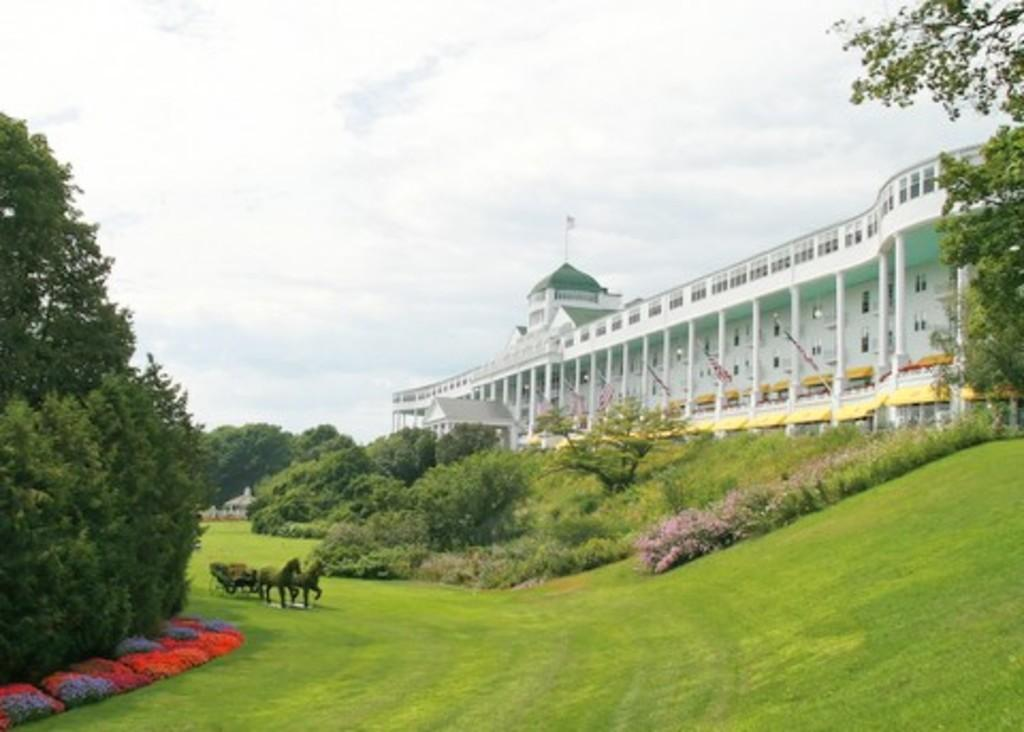What animals can be seen in the image? There are horses in the image. What is being pulled by the horses? There is a cart in the image. What type of vegetation is present in the image? There are plants, grass, flowers, and trees in the image. What type of structure can be seen in the image? There is a building in the image. What decorative elements are present in the image? There are flags in the image. What additional structure can be seen in the image? There is a shed in the image. What can be seen in the background of the image? The sky is visible in the background of the image, with clouds present. What type of silk material is draped over the horses in the image? There is no silk material present in the image; the horses are not draped in any fabric. What type of locket can be seen hanging from the cart in the image? There is no locket present in the image; the cart does not have any jewelry attached to it. 